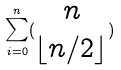<formula> <loc_0><loc_0><loc_500><loc_500>\sum _ { i = 0 } ^ { n } ( \begin{matrix} n \\ \lfloor n / 2 \rfloor \end{matrix} )</formula> 